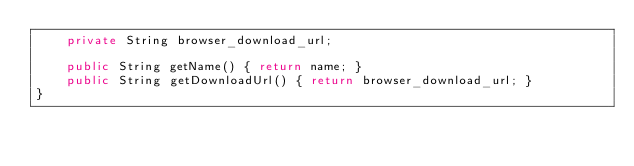<code> <loc_0><loc_0><loc_500><loc_500><_Java_>    private String browser_download_url;

    public String getName() { return name; }
    public String getDownloadUrl() { return browser_download_url; }
}
</code> 